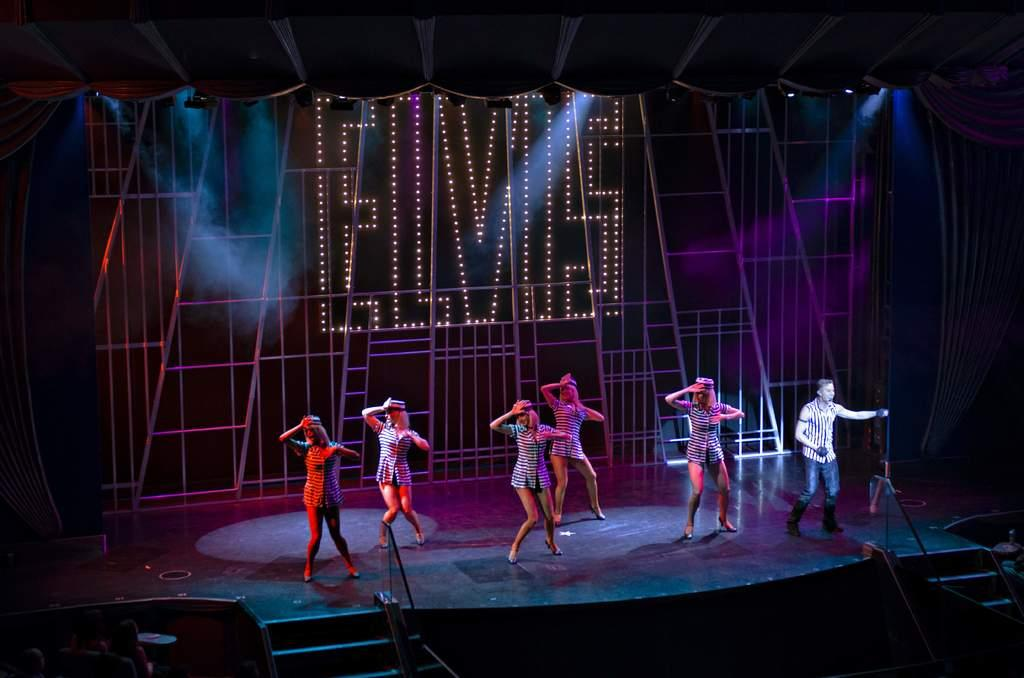How many people are in the image? There is a group of people standing in the image. What can be seen in the background of the image? There is a board and lights visible in the background of the image. What type of debt is being discussed by the group of people in the image? There is no indication of any debt being discussed in the image; it only shows a group of people standing together. 